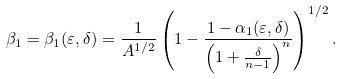<formula> <loc_0><loc_0><loc_500><loc_500>\beta _ { 1 } = \beta _ { 1 } ( \varepsilon , \delta ) = \frac { 1 } { A ^ { 1 / 2 } } \left ( 1 - \frac { 1 - \alpha _ { 1 } ( \varepsilon , \delta ) } { \left ( 1 + \frac { \delta } { n - 1 } \right ) ^ { n } } \right ) ^ { 1 / 2 } .</formula> 